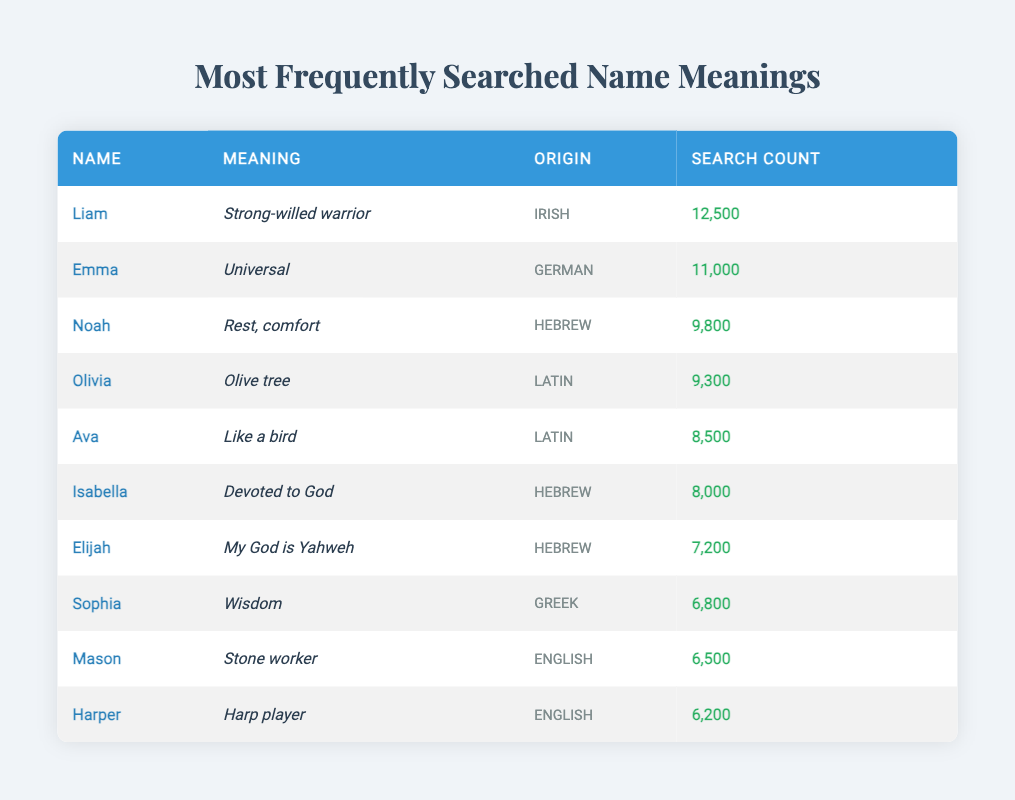What is the meaning of the name Liam? Liam's meaning, as per the data, is found in the second column of the table where the corresponding row states it is "Strong-willed warrior".
Answer: Strong-willed warrior How many times was the name Olivia searched? The search count for Olivia is located in the fourth column of its respective row, which indicates it was searched 9,300 times.
Answer: 9,300 Is the origin of the name Ava Latin? Yes, according to the data, the origin of the name Ava is listed in its row under the third column, which confirms it as "Latin".
Answer: Yes What is the average search count for the names listed in the table? To find the average search count, first sum the search counts: 12500 + 11000 + 9800 + 9300 + 8500 + 8000 + 7200 + 6800 + 6500 + 6200 = 80000. Then divide the total by the number of names (10): 80000 / 10 = 8000.
Answer: 8,000 Which name has the highest search count, and what is that count? By examining the first column of the table, it is evident that Liam has the highest search count of 12,500, as it is the first entry and the highest number in the fourth column.
Answer: Liam, 12,500 How many names have a search count greater than 8,000? By checking the search counts in the fourth column, the names with counts greater than 8,000 are Liam (12,500), Emma (11,000), Noah (9,800), Olivia (9,300), and Ava (8,500). This totals to five names.
Answer: 5 Is there a name in the table that has the meaning "Wisdom"? Yes, the name Sophia in the table indicates that its meaning is "Wisdom", as noted in the second column of its respective row.
Answer: Yes What are the origins of the names that are searched more than 8,000 times? Filtering the names by searching count, the names with counts over 8,000 are Liam (Irish), Emma (German), Noah (Hebrew), Olivia (Latin), and Ava (Latin). Therefore, the origins are Irish, German, Hebrew, Latin, and Latin.
Answer: Irish, German, Hebrew, Latin Which name has a meaning related to a profession, and what is that name? The name Mason is linked to a profession as its meaning "Stone worker" indicates a trade. This information is derived from the second column of its respective row.
Answer: Mason 